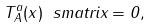<formula> <loc_0><loc_0><loc_500><loc_500>T _ { A } ^ { a } ( x ) \ s m a t r i x = 0 ,</formula> 